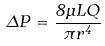<formula> <loc_0><loc_0><loc_500><loc_500>\Delta P = \frac { 8 \mu L Q } { \pi r ^ { 4 } }</formula> 